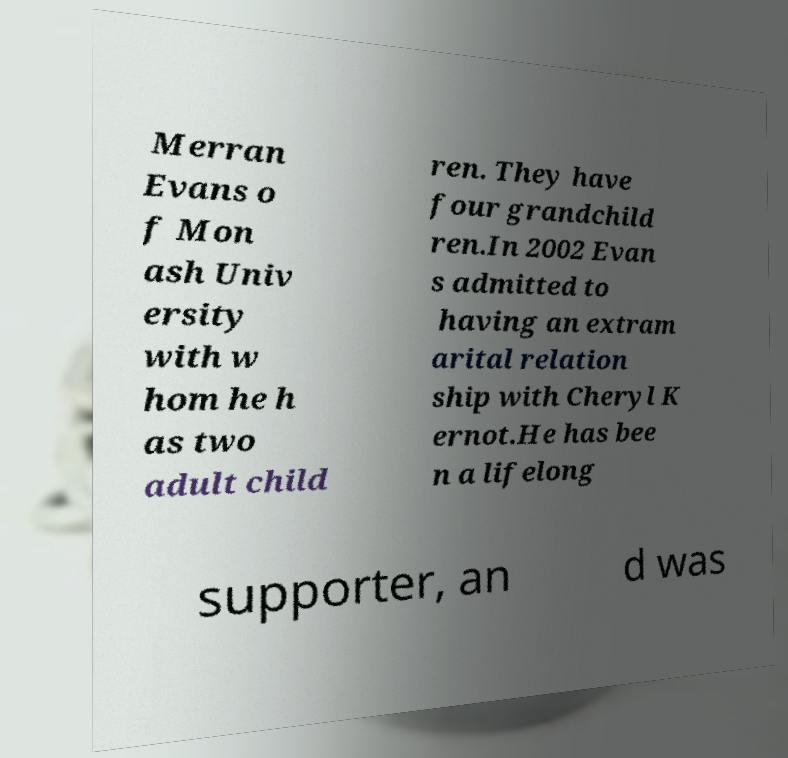Can you accurately transcribe the text from the provided image for me? Merran Evans o f Mon ash Univ ersity with w hom he h as two adult child ren. They have four grandchild ren.In 2002 Evan s admitted to having an extram arital relation ship with Cheryl K ernot.He has bee n a lifelong supporter, an d was 